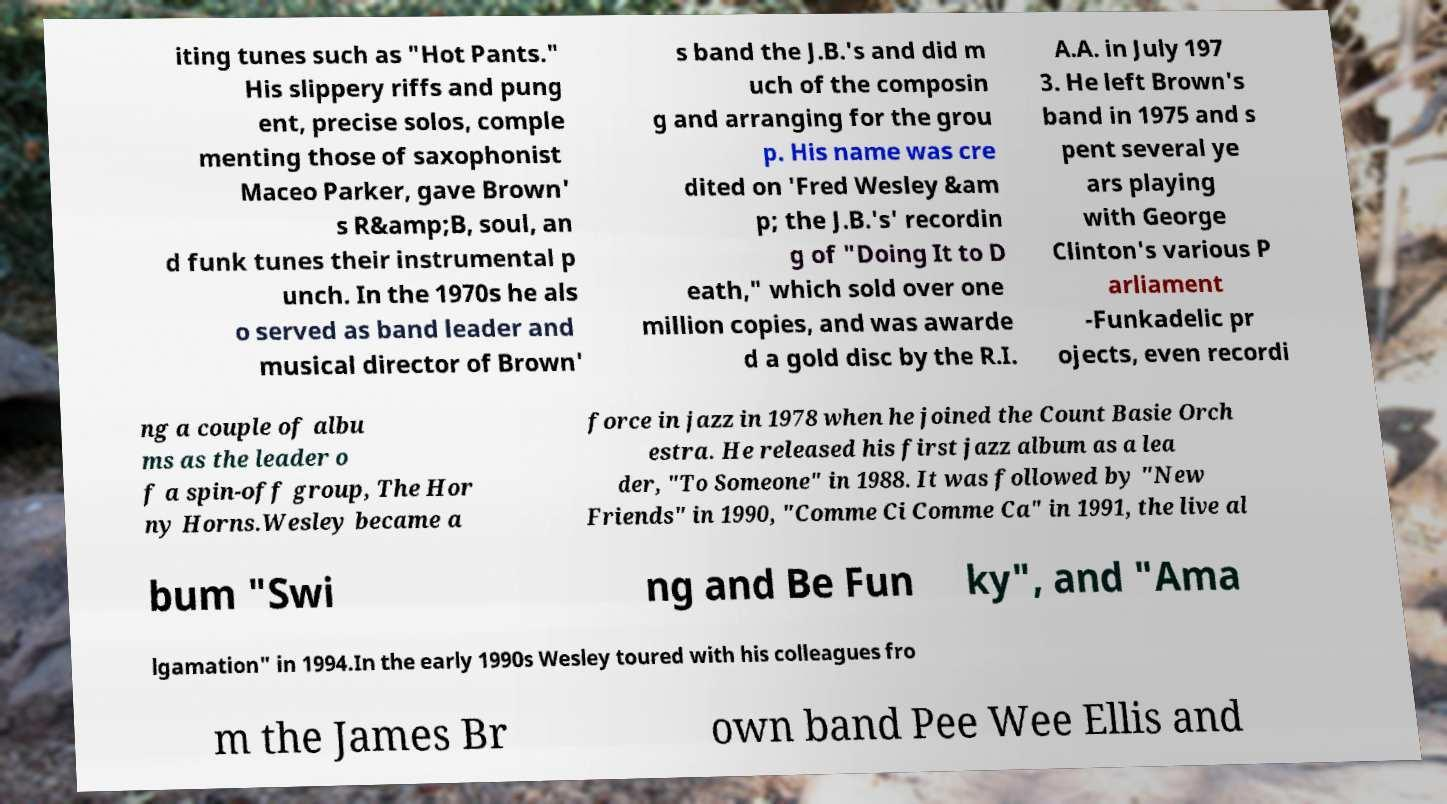Please identify and transcribe the text found in this image. iting tunes such as "Hot Pants." His slippery riffs and pung ent, precise solos, comple menting those of saxophonist Maceo Parker, gave Brown' s R&amp;B, soul, an d funk tunes their instrumental p unch. In the 1970s he als o served as band leader and musical director of Brown' s band the J.B.'s and did m uch of the composin g and arranging for the grou p. His name was cre dited on 'Fred Wesley &am p; the J.B.'s' recordin g of "Doing It to D eath," which sold over one million copies, and was awarde d a gold disc by the R.I. A.A. in July 197 3. He left Brown's band in 1975 and s pent several ye ars playing with George Clinton's various P arliament -Funkadelic pr ojects, even recordi ng a couple of albu ms as the leader o f a spin-off group, The Hor ny Horns.Wesley became a force in jazz in 1978 when he joined the Count Basie Orch estra. He released his first jazz album as a lea der, "To Someone" in 1988. It was followed by "New Friends" in 1990, "Comme Ci Comme Ca" in 1991, the live al bum "Swi ng and Be Fun ky", and "Ama lgamation" in 1994.In the early 1990s Wesley toured with his colleagues fro m the James Br own band Pee Wee Ellis and 